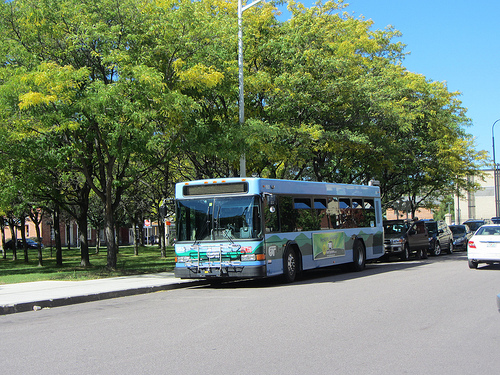Is the person to the left or to the right of the bus the tree is behind of? The person is to the right of the bus that the tree is behind. 